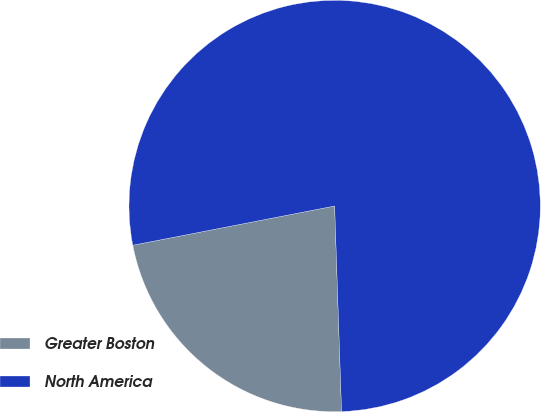<chart> <loc_0><loc_0><loc_500><loc_500><pie_chart><fcel>Greater Boston<fcel>North America<nl><fcel>22.48%<fcel>77.52%<nl></chart> 